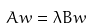Convert formula to latex. <formula><loc_0><loc_0><loc_500><loc_500>A w = \lambda B w</formula> 